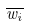<formula> <loc_0><loc_0><loc_500><loc_500>\overline { w _ { i } }</formula> 